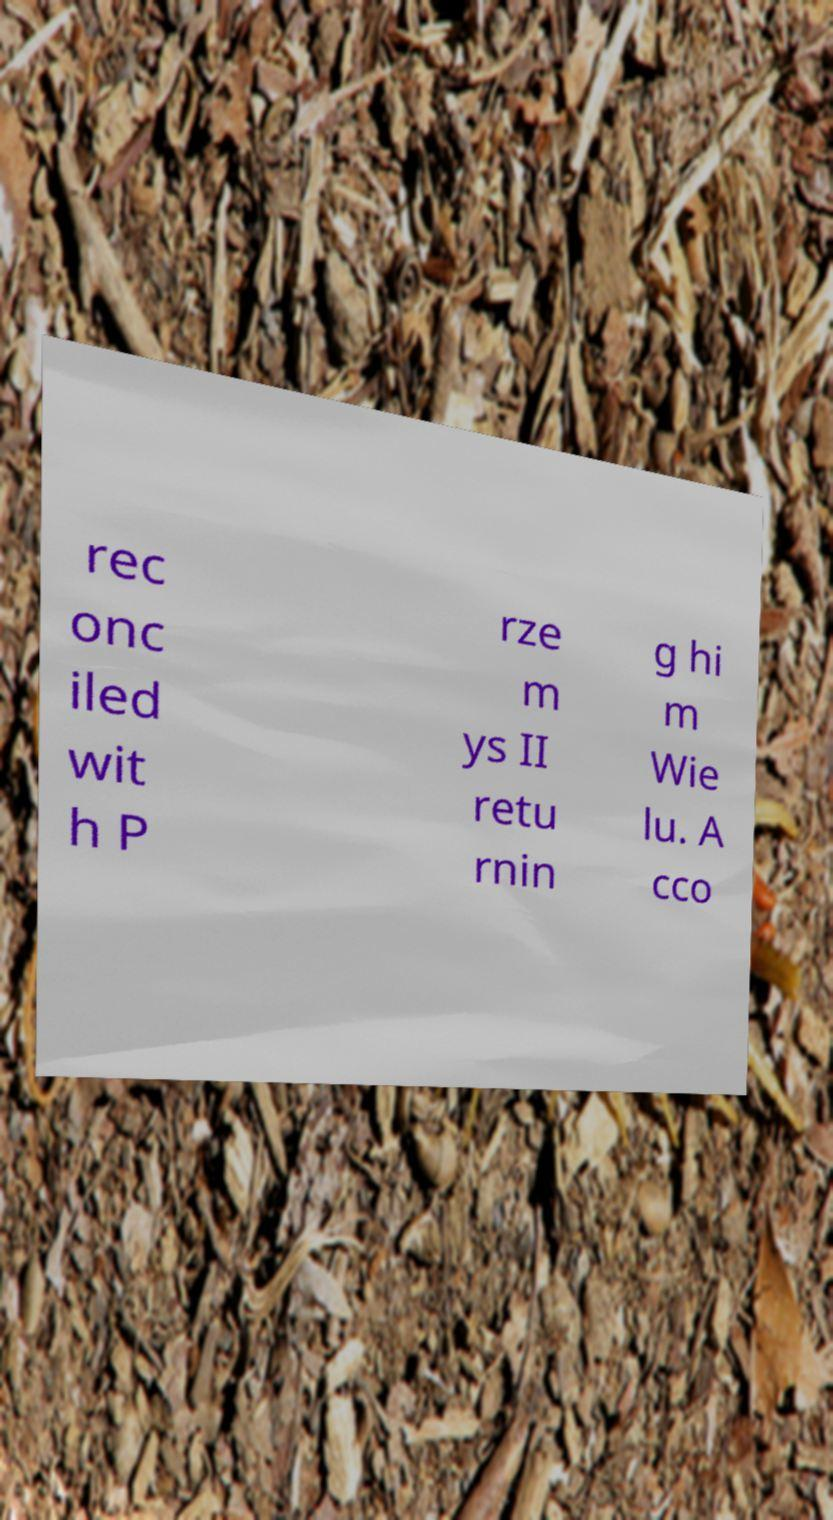Could you extract and type out the text from this image? rec onc iled wit h P rze m ys II retu rnin g hi m Wie lu. A cco 